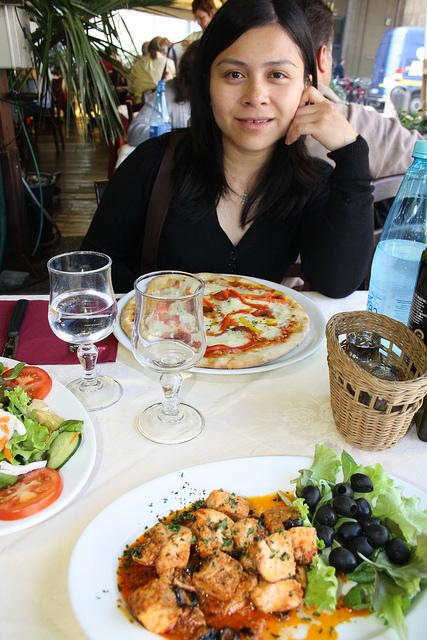What is the woman in black about to eat? Please explain your reasoning. pizza. She has circular dough with cheese and sauce on top 